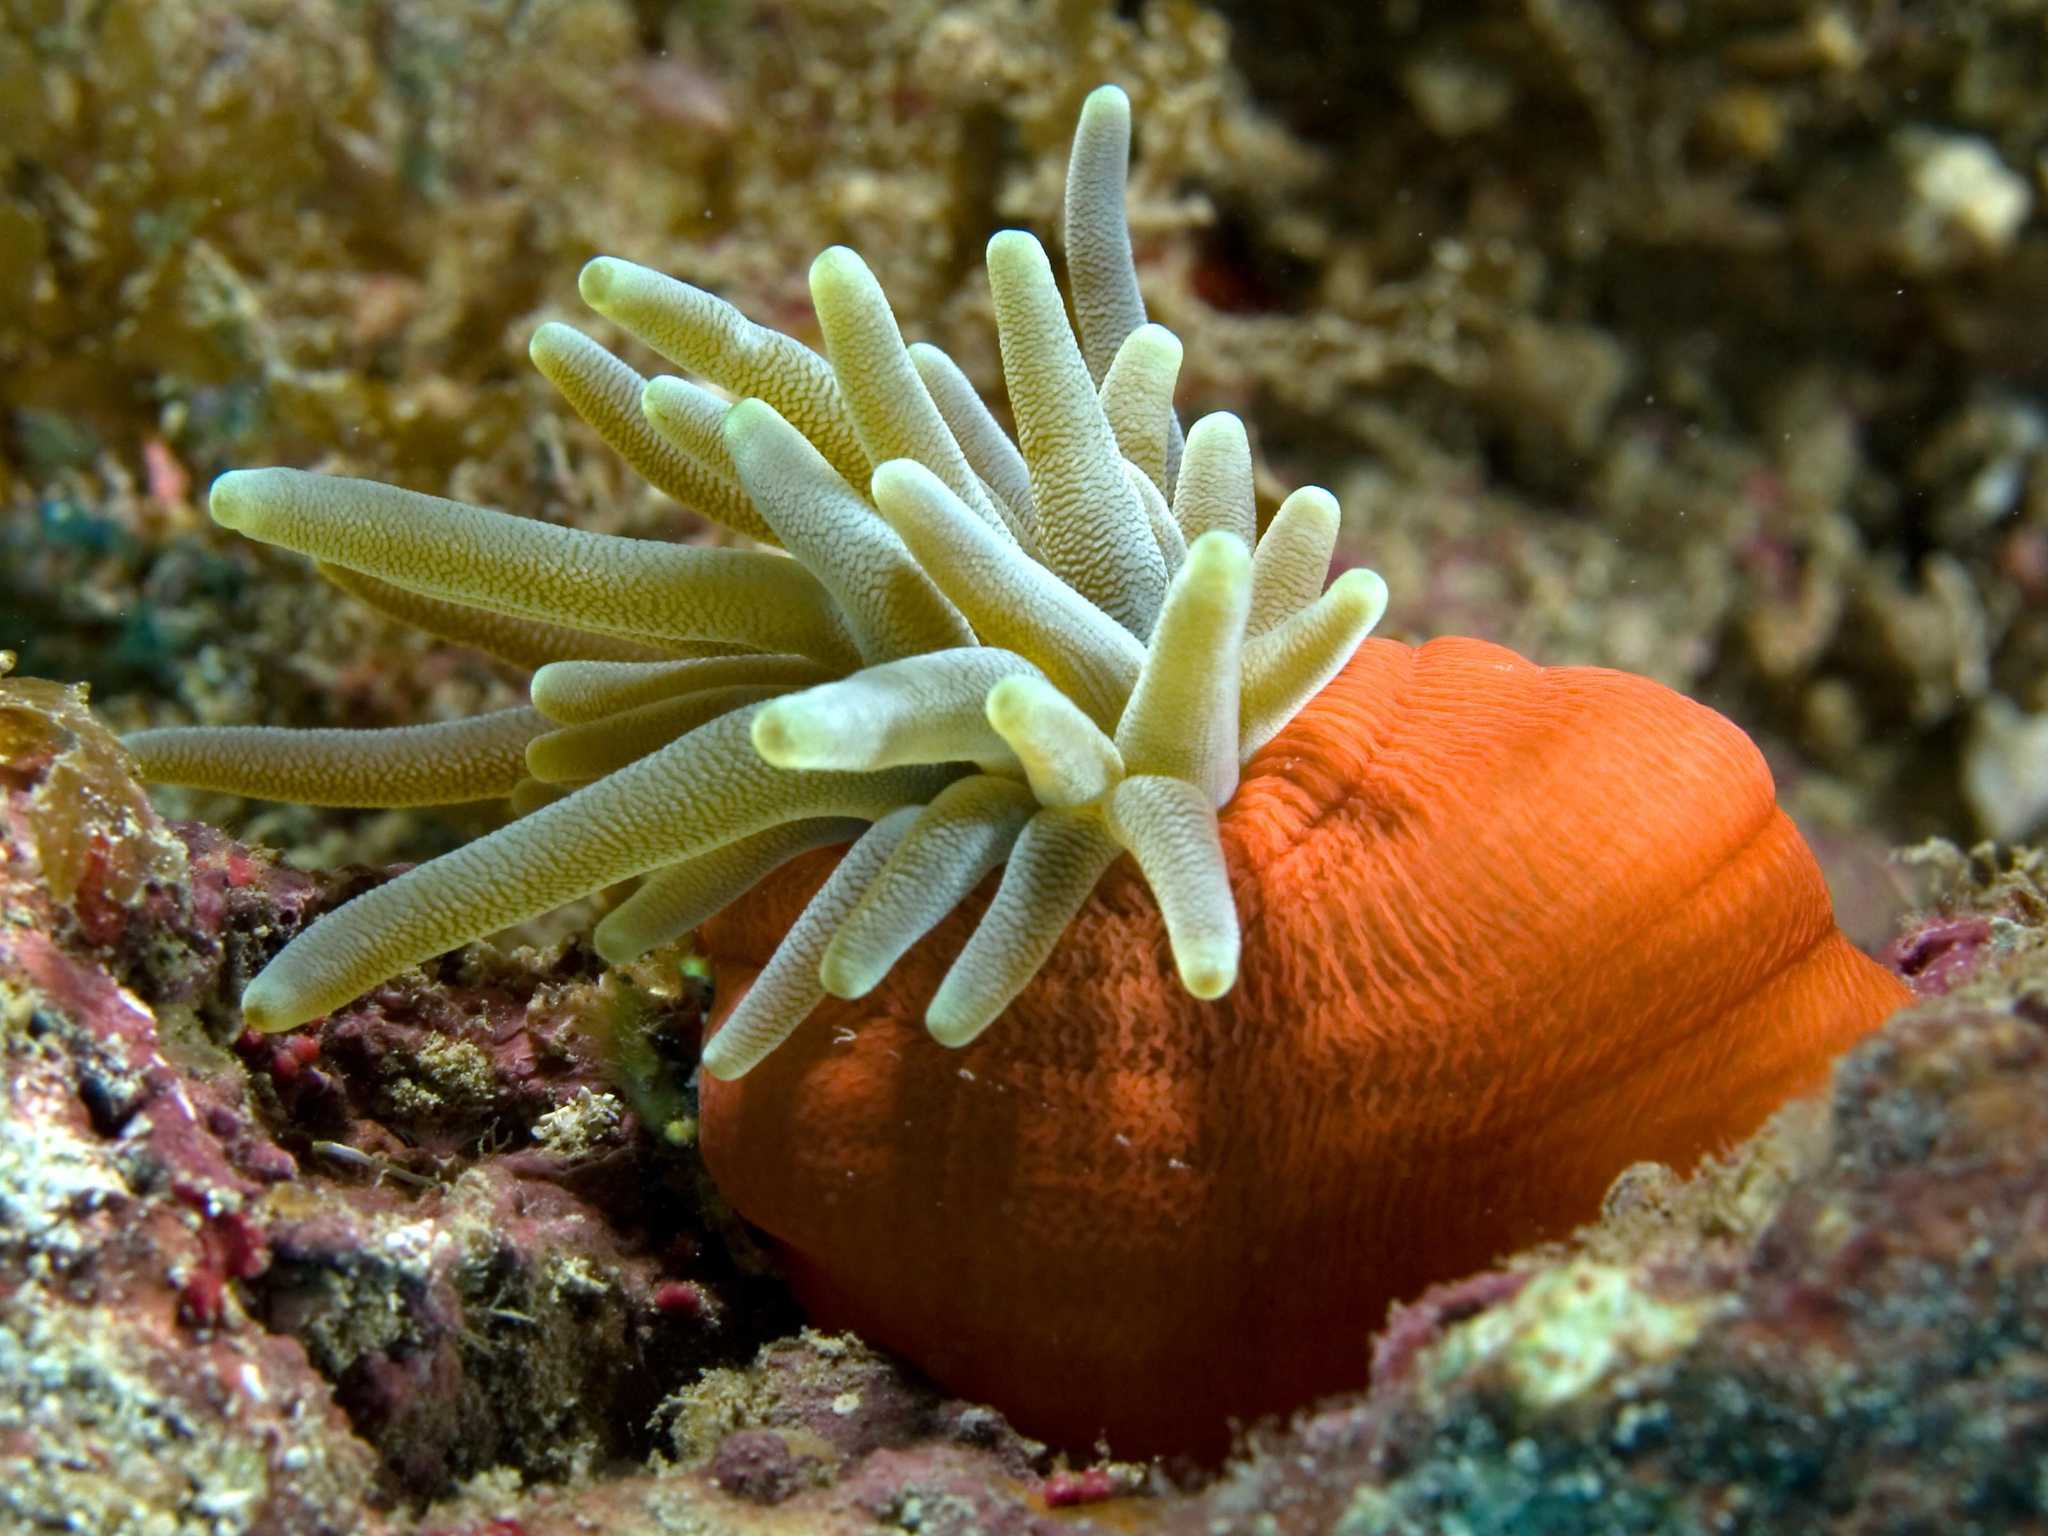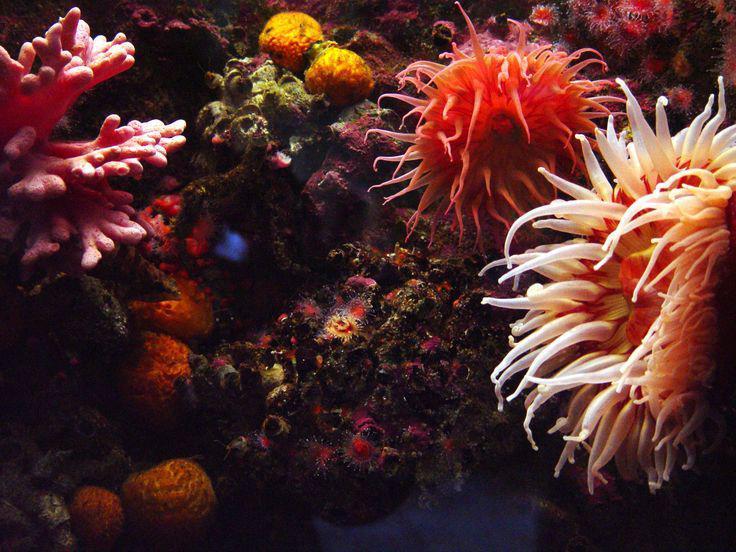The first image is the image on the left, the second image is the image on the right. Given the left and right images, does the statement "The left image contains one anemone, which has orangish color, tapered tendrils, and a darker center with a """"mouth"""" opening." hold true? Answer yes or no. No. 